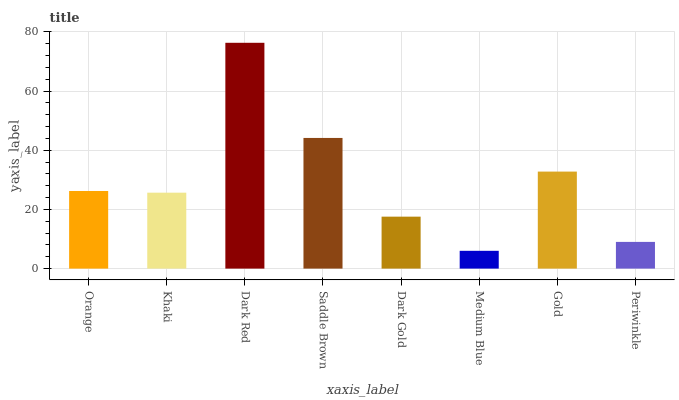Is Medium Blue the minimum?
Answer yes or no. Yes. Is Dark Red the maximum?
Answer yes or no. Yes. Is Khaki the minimum?
Answer yes or no. No. Is Khaki the maximum?
Answer yes or no. No. Is Orange greater than Khaki?
Answer yes or no. Yes. Is Khaki less than Orange?
Answer yes or no. Yes. Is Khaki greater than Orange?
Answer yes or no. No. Is Orange less than Khaki?
Answer yes or no. No. Is Orange the high median?
Answer yes or no. Yes. Is Khaki the low median?
Answer yes or no. Yes. Is Khaki the high median?
Answer yes or no. No. Is Medium Blue the low median?
Answer yes or no. No. 